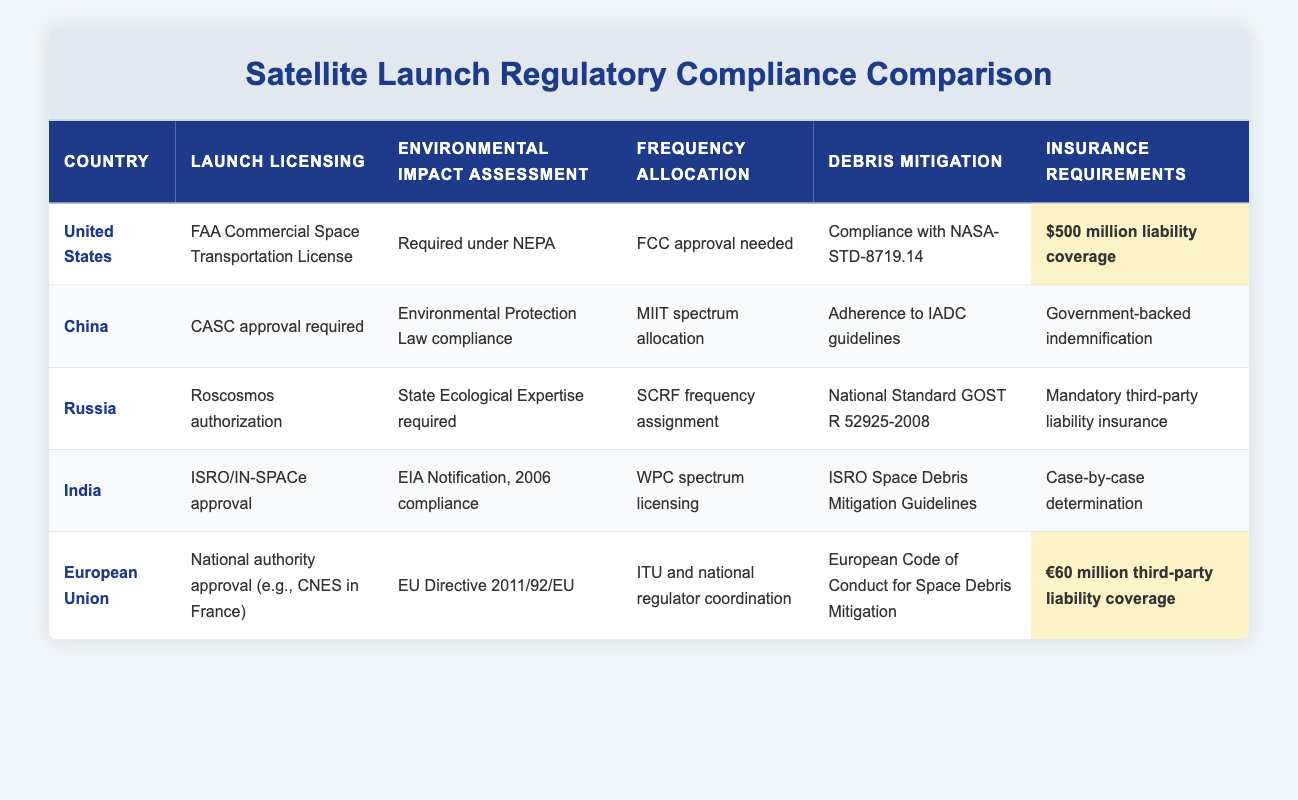What is the insurance requirement for the United States? The table shows that the insurance requirement for the United States is "$500 million liability coverage." This information is found under the "Insurance Requirements" column for the corresponding country row.
Answer: $500 million liability coverage Which country requires government-backed indemnification for satellite launch insurance? In the table, the insurance requirement for China is listed as "Government-backed indemnification." This answers the question as it matches the requirement specified.
Answer: China Do all countries listed have an environmental impact assessment requirement? By examining the table, we see that all five countries listed (United States, China, Russia, India, and European Union) have specific environmental impact assessment requirements. Thus, the answer is yes.
Answer: Yes Which country has the highest minimum insurance liability coverage? The United States has a requirement of "$500 million liability coverage," while the European Union has a coverage of "€60 million." Comparing these values indicates that the U.S. has the highest minimum insurance liability coverage.
Answer: United States What is the difference between the launch licensing processes for India and Russia? India requires "ISRO/IN-SPACe approval," while Russia requires "Roscosmos authorization." The difference here is the specific agencies that handle licensing for launches in each respective country.
Answer: ISRO/IN-SPACe approval vs. Roscosmos authorization Which country requires compliance with NASA-STD-8719.14 for debris mitigation? Referring to the table, the United States has a specific requirement for debris mitigation of "Compliance with NASA-STD-8719.14." This is a unique aspect pertaining to U.S. regulations.
Answer: United States How many countries require an ecological or environmental expert assessment for satellite launches? The table lists that the countries involved are the United States, China, Russia, and India, each specifying a form of ecological or environmental assessment. Thus, there are four countries with this requirement.
Answer: 4 What are the frequency allocation processes in the European Union compared to the United States? The United States requires "FCC approval needed" for frequency allocation, whereas the European Union needs "ITU and national regulator coordination." This demonstrates that the U.S. has a single agency involved while the EU relies on a coordination of entities.
Answer: FCC approval vs. ITU and national coordination 